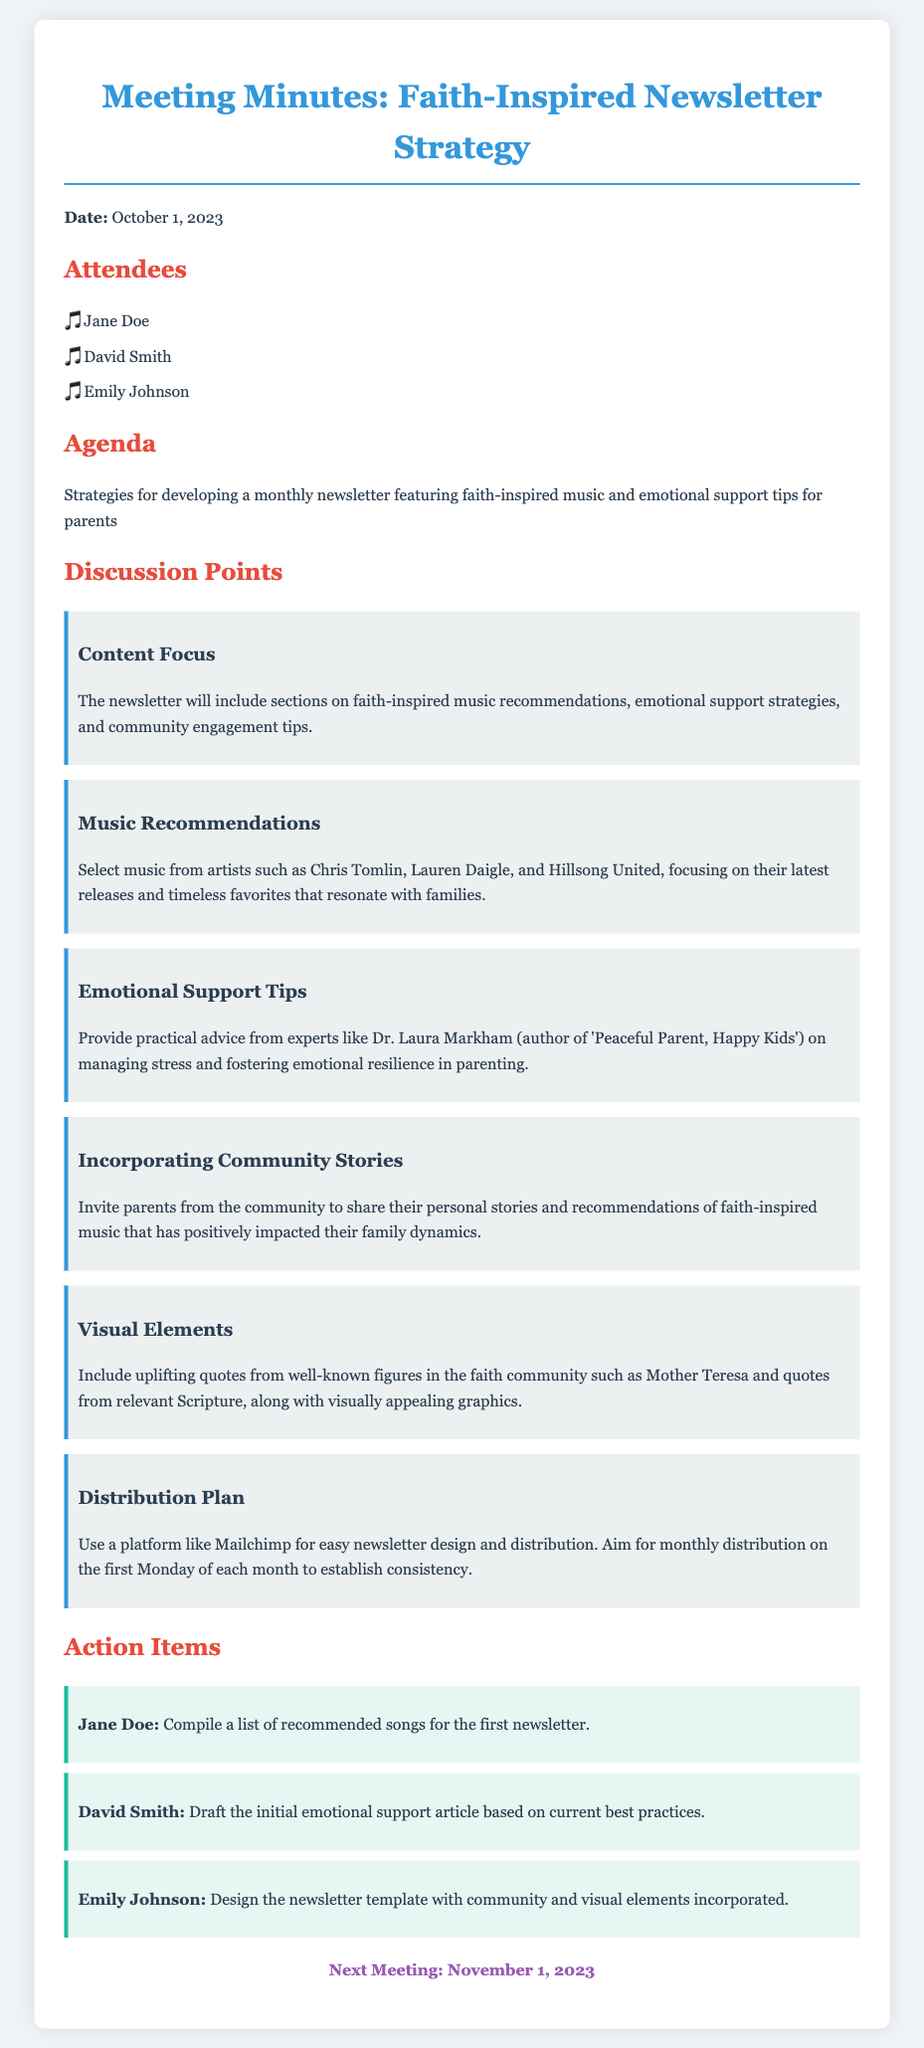what is the date of the meeting? The date of the meeting is explicitly stated in the document as October 1, 2023.
Answer: October 1, 2023 who is responsible for compiling the song list? The action item for compiling a list of recommended songs is assigned to Jane Doe.
Answer: Jane Doe what platform is suggested for newsletter distribution? The document specifies Mailchimp as the chosen platform for easy design and distribution of the newsletter.
Answer: Mailchimp how often will the newsletter be distributed? The meeting minutes indicate that the newsletter will be distributed monthly, specifically on the first Monday of each month.
Answer: Monthly who will draft the emotional support article? The action item for drafting the initial emotional support article is assigned to David Smith.
Answer: David Smith what is one type of content highlighted in the newsletter? The document highlights that the newsletter includes emotional support strategies as one of its content focuses.
Answer: Emotional support strategies what is a suggested source for emotional support advice? Dr. Laura Markham's book 'Peaceful Parent, Happy Kids' is mentioned as a source for practical advice.
Answer: Dr. Laura Markham what type of quotes will be included in the newsletter? Uplifting quotes from well-known figures in the faith community like Mother Teresa will be included.
Answer: Uplifting quotes when is the next meeting scheduled? The next meeting date is clearly stated as November 1, 2023.
Answer: November 1, 2023 